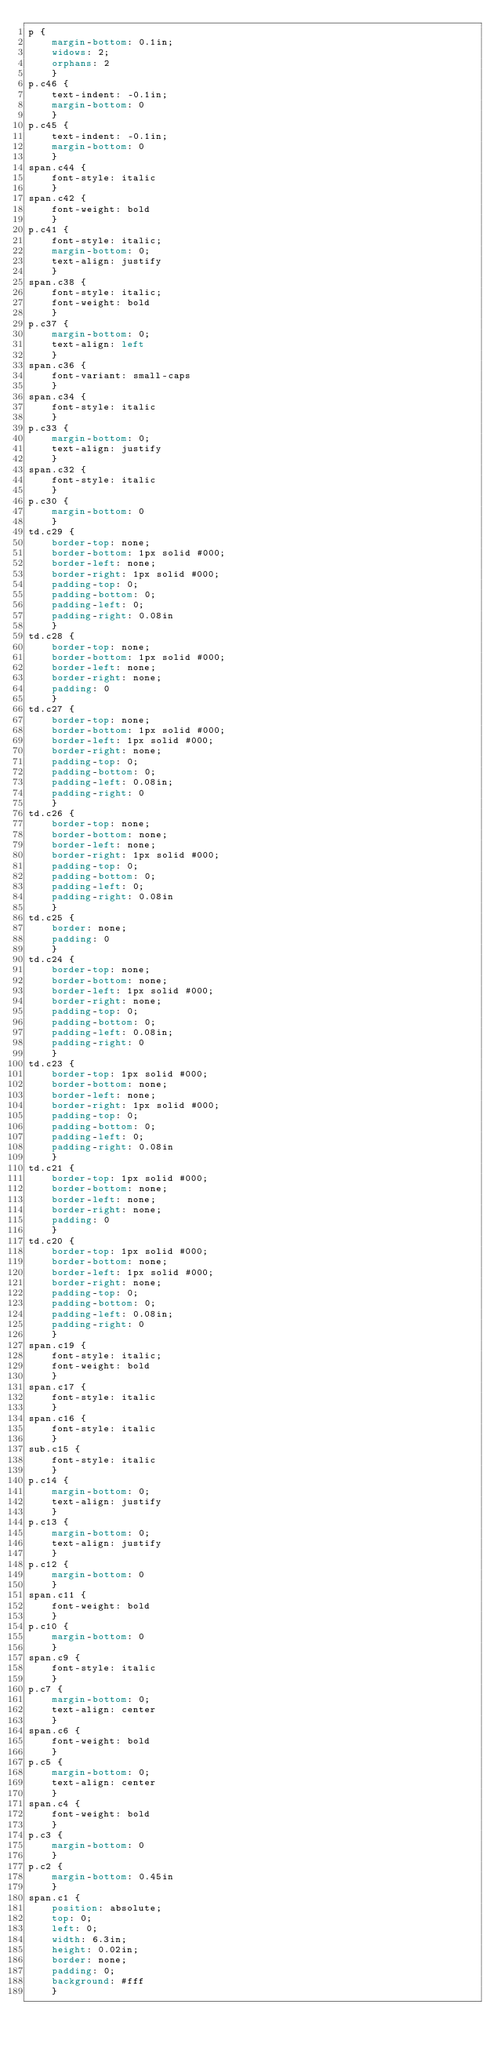<code> <loc_0><loc_0><loc_500><loc_500><_CSS_>p {
    margin-bottom: 0.1in;
    widows: 2;
    orphans: 2
    }
p.c46 {
    text-indent: -0.1in;
    margin-bottom: 0
    }
p.c45 {
    text-indent: -0.1in;
    margin-bottom: 0
    }
span.c44 {
    font-style: italic
    }
span.c42 {
    font-weight: bold
    }
p.c41 {
    font-style: italic;
    margin-bottom: 0;
    text-align: justify
    }
span.c38 {
    font-style: italic;
    font-weight: bold
    }
p.c37 {
    margin-bottom: 0;
    text-align: left
    }
span.c36 {
    font-variant: small-caps
    }
span.c34 {
    font-style: italic
    }
p.c33 {
    margin-bottom: 0;
    text-align: justify
    }
span.c32 {
    font-style: italic
    }
p.c30 {
    margin-bottom: 0
    }
td.c29 {
    border-top: none;
    border-bottom: 1px solid #000;
    border-left: none;
    border-right: 1px solid #000;
    padding-top: 0;
    padding-bottom: 0;
    padding-left: 0;
    padding-right: 0.08in
    }
td.c28 {
    border-top: none;
    border-bottom: 1px solid #000;
    border-left: none;
    border-right: none;
    padding: 0
    }
td.c27 {
    border-top: none;
    border-bottom: 1px solid #000;
    border-left: 1px solid #000;
    border-right: none;
    padding-top: 0;
    padding-bottom: 0;
    padding-left: 0.08in;
    padding-right: 0
    }
td.c26 {
    border-top: none;
    border-bottom: none;
    border-left: none;
    border-right: 1px solid #000;
    padding-top: 0;
    padding-bottom: 0;
    padding-left: 0;
    padding-right: 0.08in
    }
td.c25 {
    border: none;
    padding: 0
    }
td.c24 {
    border-top: none;
    border-bottom: none;
    border-left: 1px solid #000;
    border-right: none;
    padding-top: 0;
    padding-bottom: 0;
    padding-left: 0.08in;
    padding-right: 0
    }
td.c23 {
    border-top: 1px solid #000;
    border-bottom: none;
    border-left: none;
    border-right: 1px solid #000;
    padding-top: 0;
    padding-bottom: 0;
    padding-left: 0;
    padding-right: 0.08in
    }
td.c21 {
    border-top: 1px solid #000;
    border-bottom: none;
    border-left: none;
    border-right: none;
    padding: 0
    }
td.c20 {
    border-top: 1px solid #000;
    border-bottom: none;
    border-left: 1px solid #000;
    border-right: none;
    padding-top: 0;
    padding-bottom: 0;
    padding-left: 0.08in;
    padding-right: 0
    }
span.c19 {
    font-style: italic;
    font-weight: bold
    }
span.c17 {
    font-style: italic
    }
span.c16 {
    font-style: italic
    }
sub.c15 {
    font-style: italic
    }
p.c14 {
    margin-bottom: 0;
    text-align: justify
    }
p.c13 {
    margin-bottom: 0;
    text-align: justify
    }
p.c12 {
    margin-bottom: 0
    }
span.c11 {
    font-weight: bold
    }
p.c10 {
    margin-bottom: 0
    }
span.c9 {
    font-style: italic
    }
p.c7 {
    margin-bottom: 0;
    text-align: center
    }
span.c6 {
    font-weight: bold
    }
p.c5 {
    margin-bottom: 0;
    text-align: center
    }
span.c4 {
    font-weight: bold
    }
p.c3 {
    margin-bottom: 0
    }
p.c2 {
    margin-bottom: 0.45in
    }
span.c1 {
    position: absolute;
    top: 0;
    left: 0;
    width: 6.3in;
    height: 0.02in;
    border: none;
    padding: 0;
    background: #fff
    }</code> 